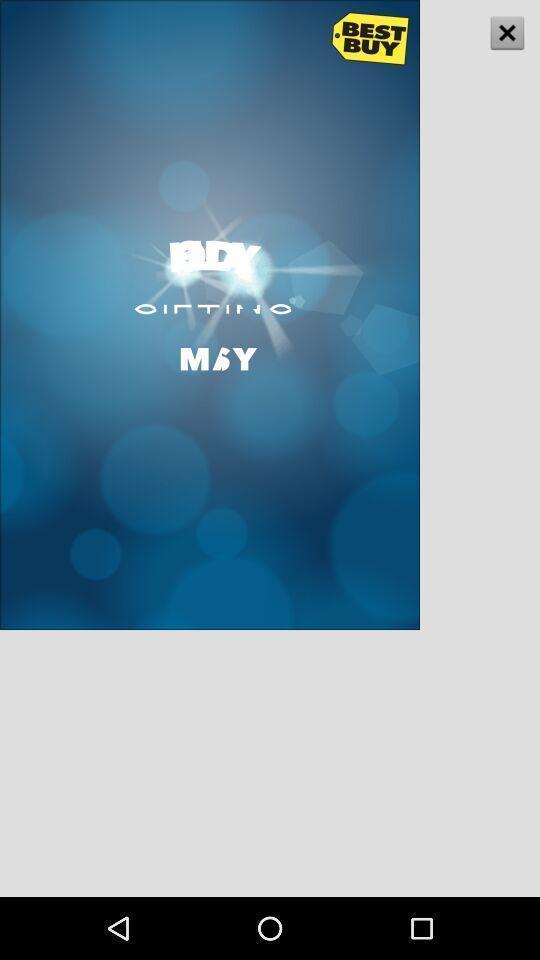What can you discern from this picture? Screen shows about a fitness journey to stay on track. 